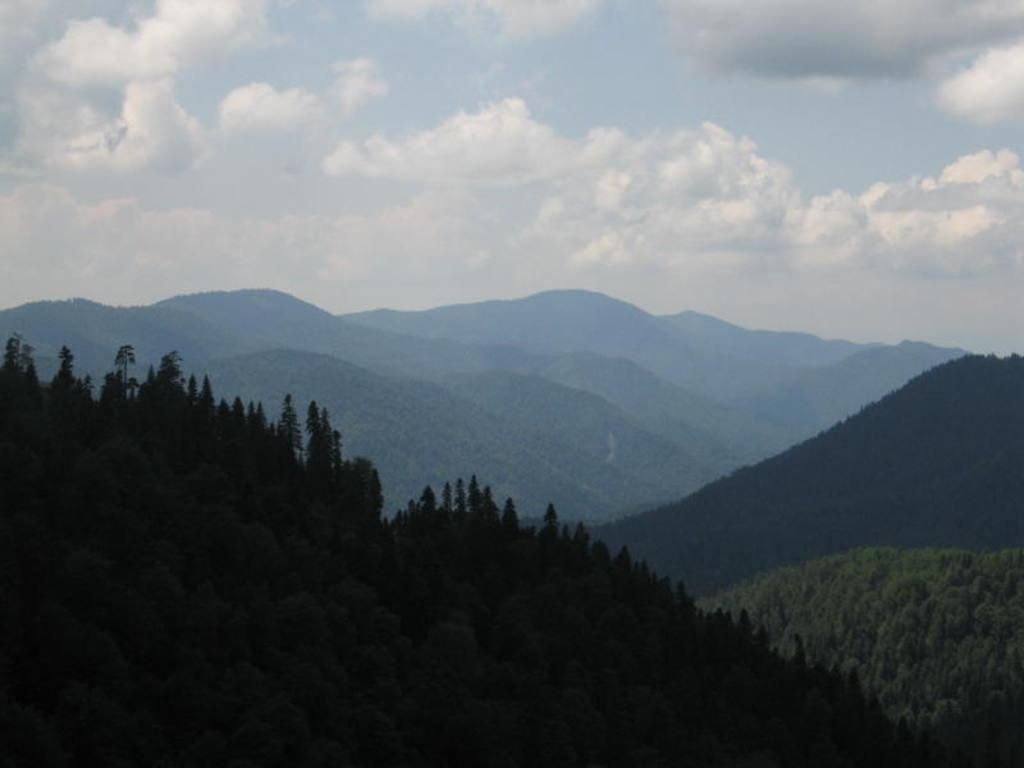What type of vegetation can be seen in the image? There are trees in the image. What type of landscape feature is present in the image? There are hills in the image. What is visible in the sky in the image? The sky is visible in the image. What can be observed in the sky in the image? Clouds are present in the sky. What type of reaction can be seen in the image? There is no reaction present in the image; it features trees, hills, sky, and clouds. What type of patch is visible on the trees in the image? There are no patches visible on the trees in the image; it only features trees, hills, sky, and clouds. 